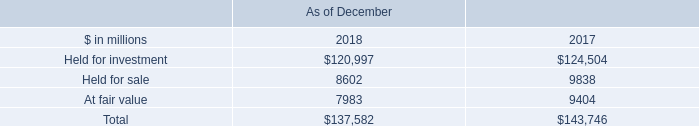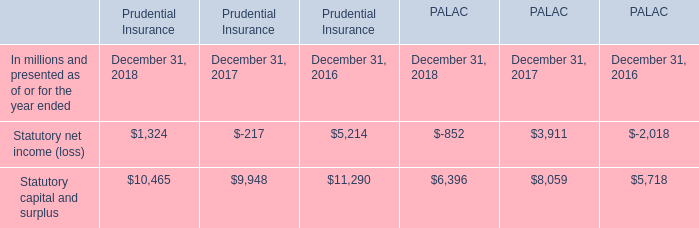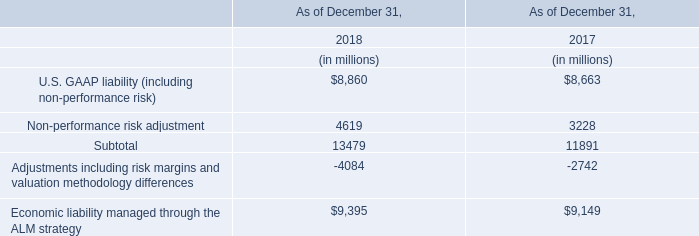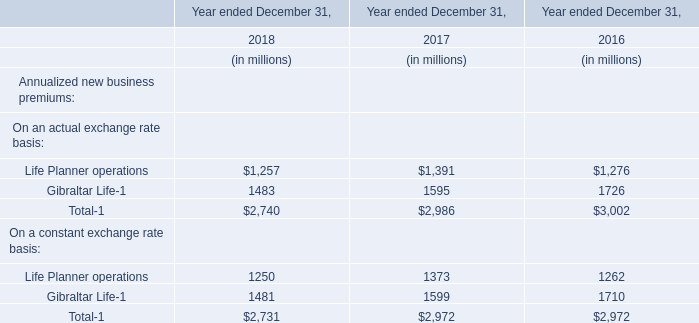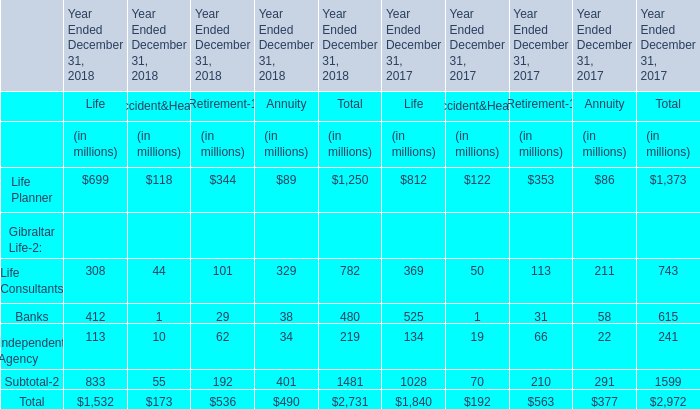What's the average of Statutory capital and surplus of Prudential Insurance December 31, 2018, and Held for investment of As of December 2017 ? 
Computations: ((10465.0 + 124504.0) / 2)
Answer: 67484.5. 